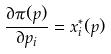Convert formula to latex. <formula><loc_0><loc_0><loc_500><loc_500>\frac { \partial \pi ( p ) } { \partial p _ { i } } = x _ { i } ^ { * } ( p )</formula> 